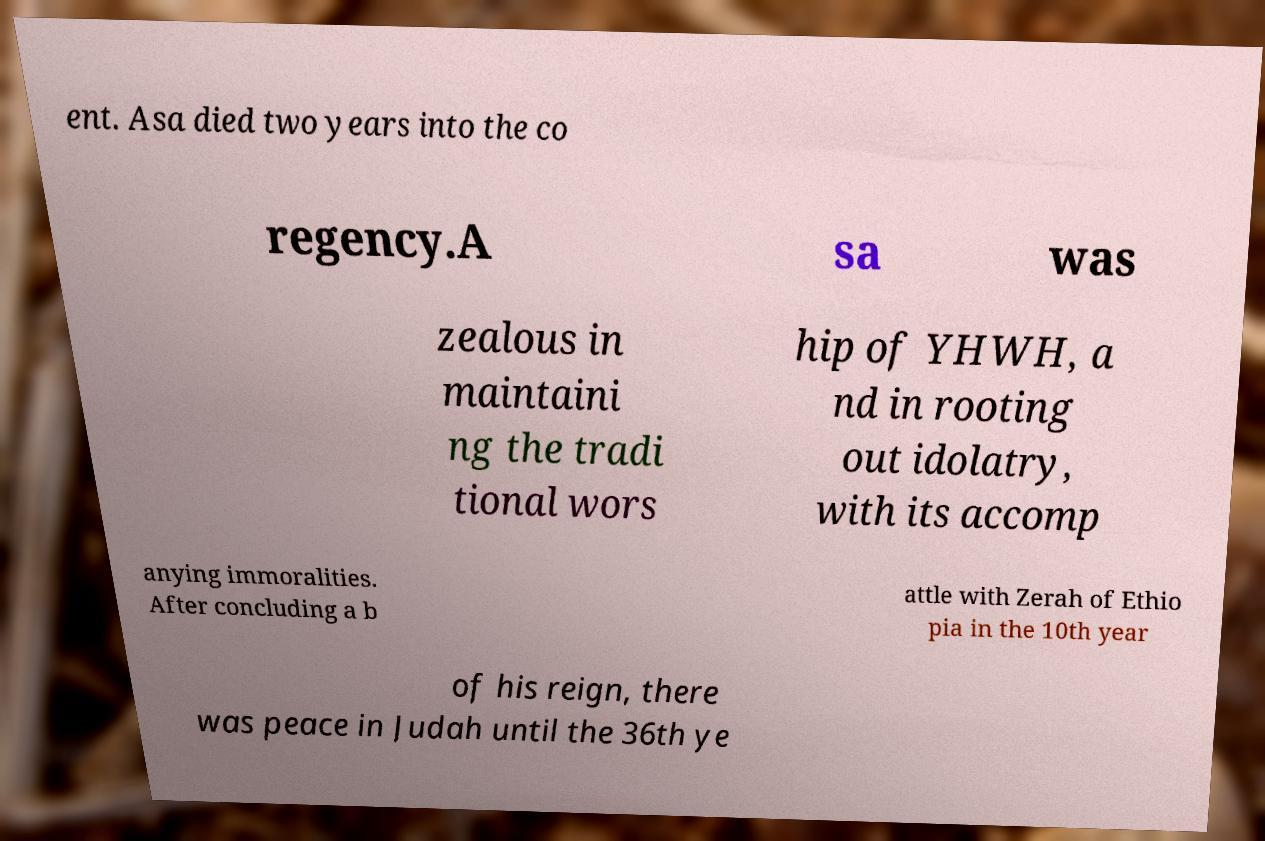Please read and relay the text visible in this image. What does it say? ent. Asa died two years into the co regency.A sa was zealous in maintaini ng the tradi tional wors hip of YHWH, a nd in rooting out idolatry, with its accomp anying immoralities. After concluding a b attle with Zerah of Ethio pia in the 10th year of his reign, there was peace in Judah until the 36th ye 